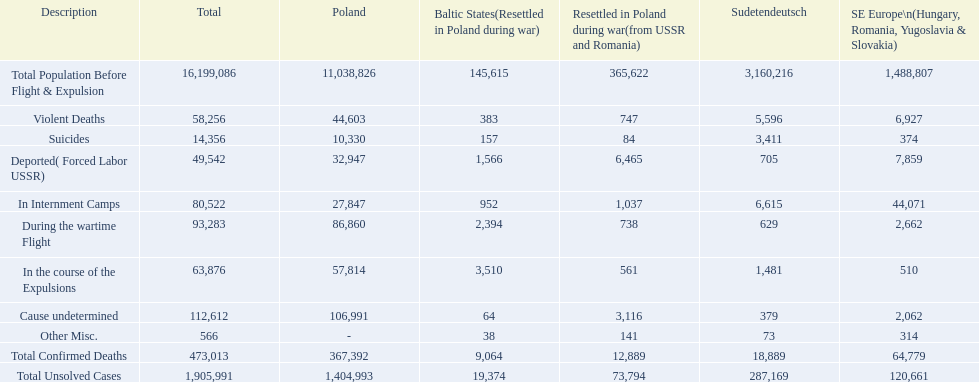What are the death counts for each category in the baltic states? 145,615, 383, 157, 1,566, 952, 2,394, 3,510, 64, 38, 9,064, 19,374. How many deaths in the baltic states are attributed to an undetermined cause? 64. How many deaths in the baltic states fall under other miscellaneous categories? 38. Which category has more deaths: undetermined cause or other miscellaneous? Cause undetermined. 